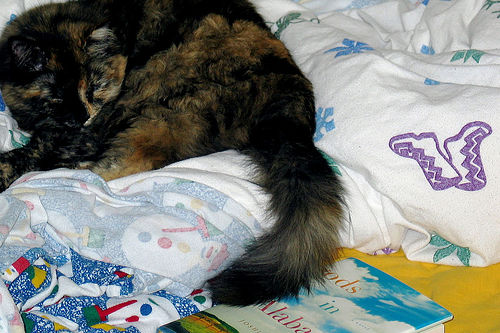<image>
Is the cat behind the book? Yes. From this viewpoint, the cat is positioned behind the book, with the book partially or fully occluding the cat. Where is the cat in relation to the blanket? Is it to the left of the blanket? Yes. From this viewpoint, the cat is positioned to the left side relative to the blanket. 